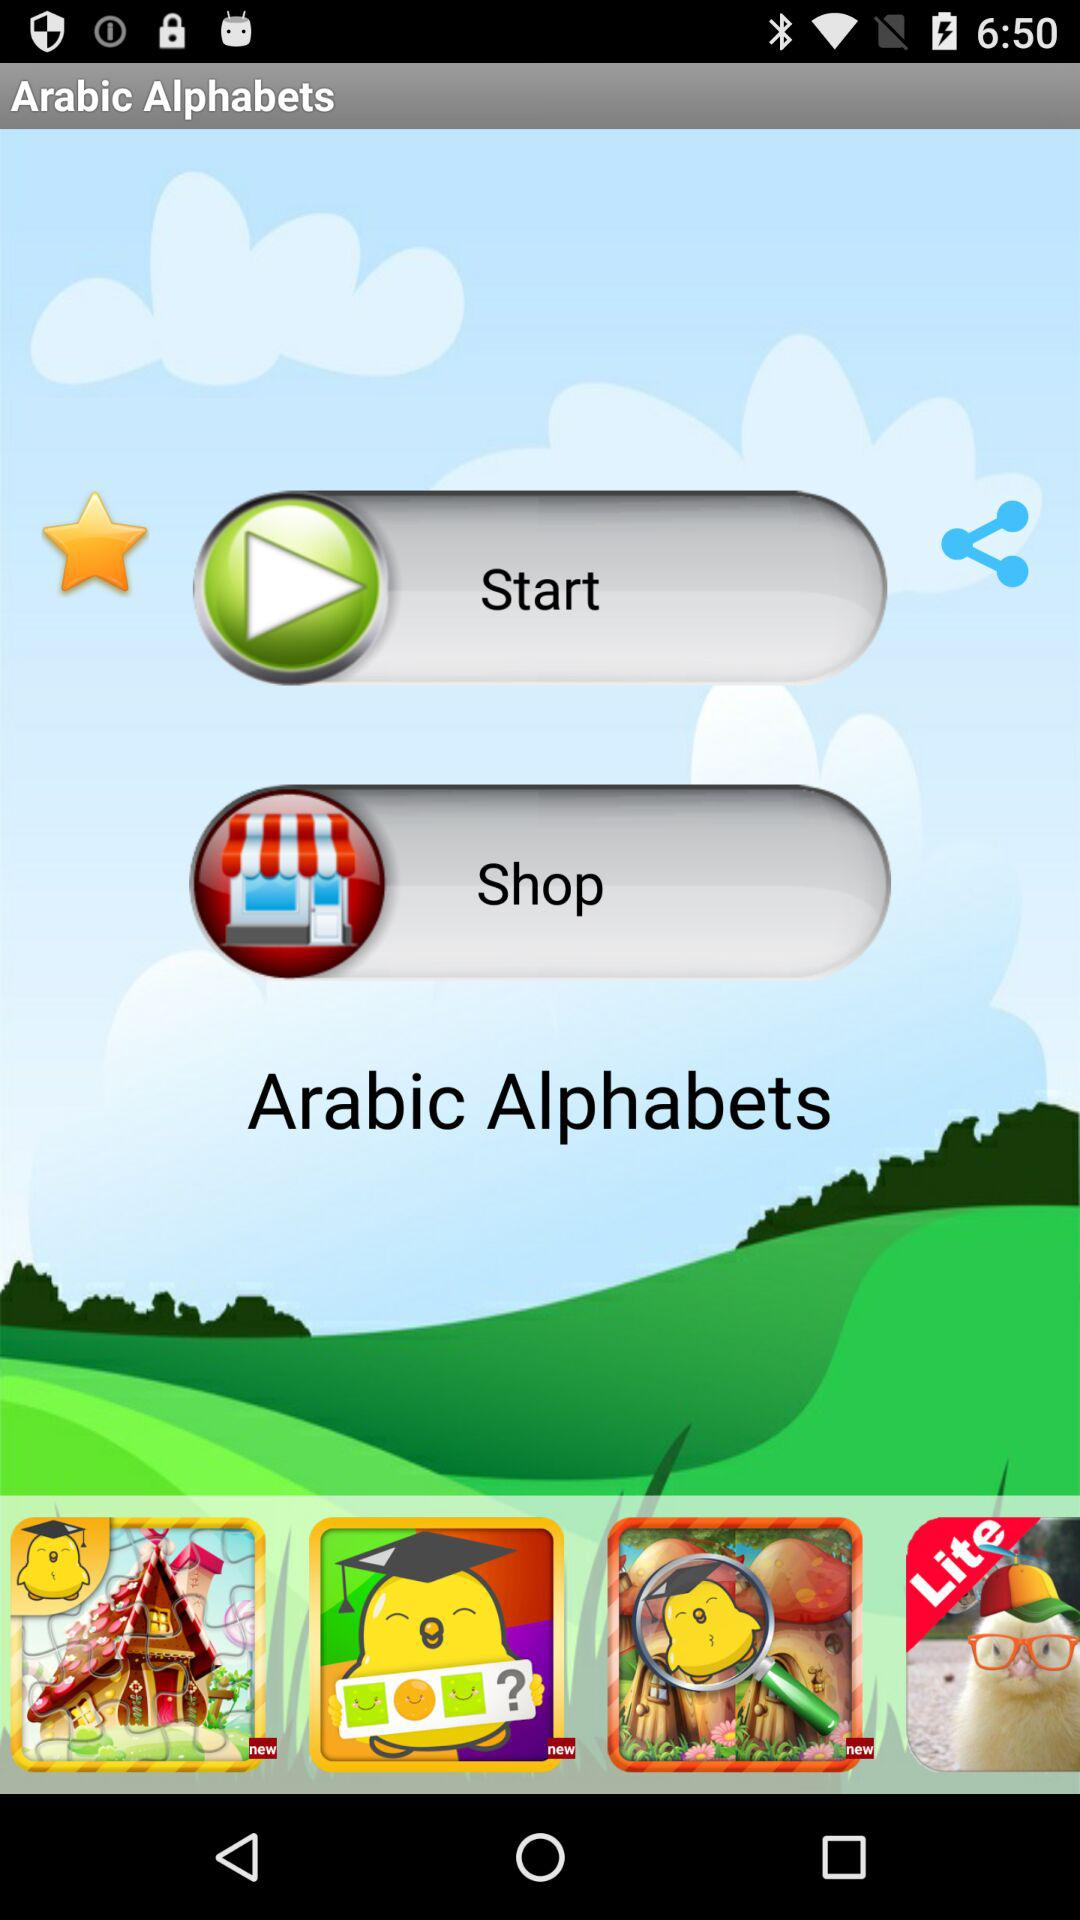What is the name of the application? The name of the application is "Arabic Alphabets". 